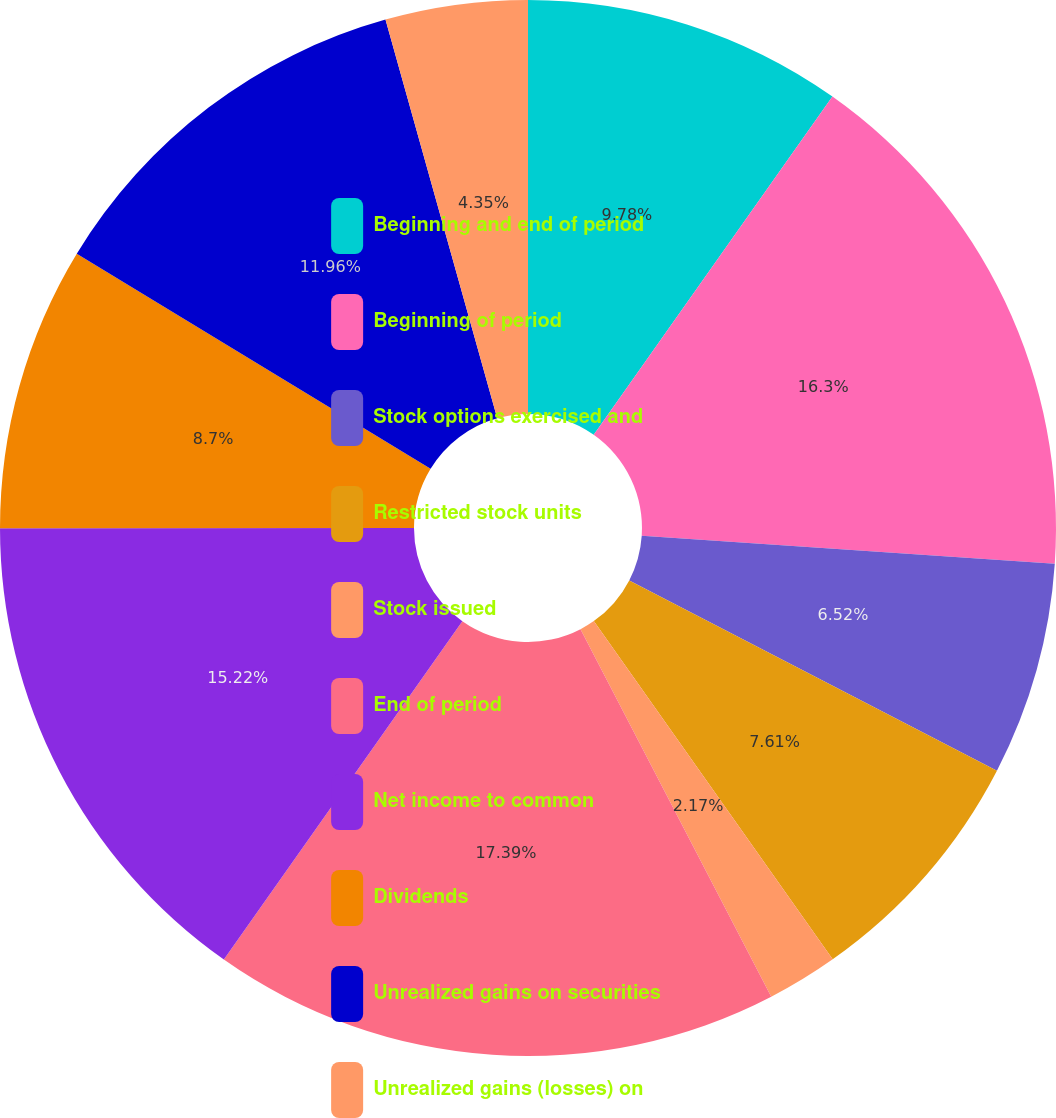Convert chart. <chart><loc_0><loc_0><loc_500><loc_500><pie_chart><fcel>Beginning and end of period<fcel>Beginning of period<fcel>Stock options exercised and<fcel>Restricted stock units<fcel>Stock issued<fcel>End of period<fcel>Net income to common<fcel>Dividends<fcel>Unrealized gains on securities<fcel>Unrealized gains (losses) on<nl><fcel>9.78%<fcel>16.3%<fcel>6.52%<fcel>7.61%<fcel>2.17%<fcel>17.39%<fcel>15.22%<fcel>8.7%<fcel>11.96%<fcel>4.35%<nl></chart> 